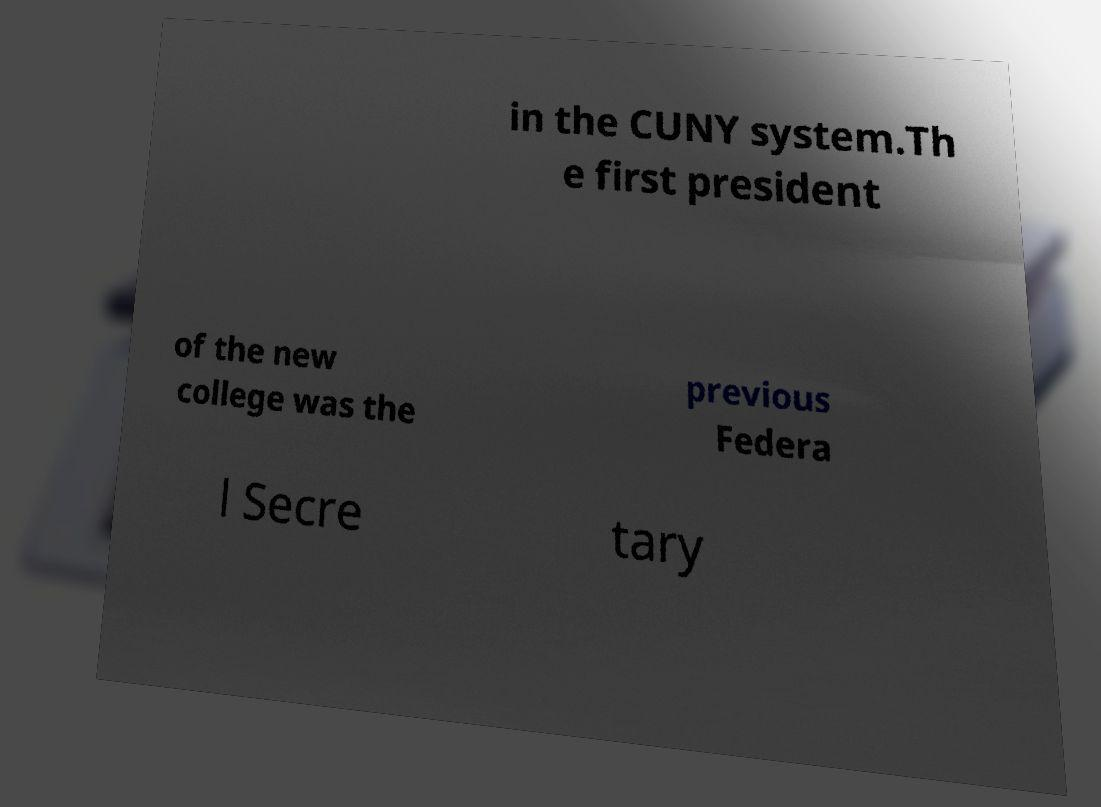Please identify and transcribe the text found in this image. in the CUNY system.Th e first president of the new college was the previous Federa l Secre tary 